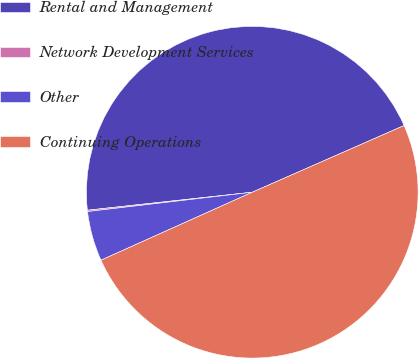Convert chart to OTSL. <chart><loc_0><loc_0><loc_500><loc_500><pie_chart><fcel>Rental and Management<fcel>Network Development Services<fcel>Other<fcel>Continuing Operations<nl><fcel>45.14%<fcel>0.13%<fcel>4.86%<fcel>49.87%<nl></chart> 